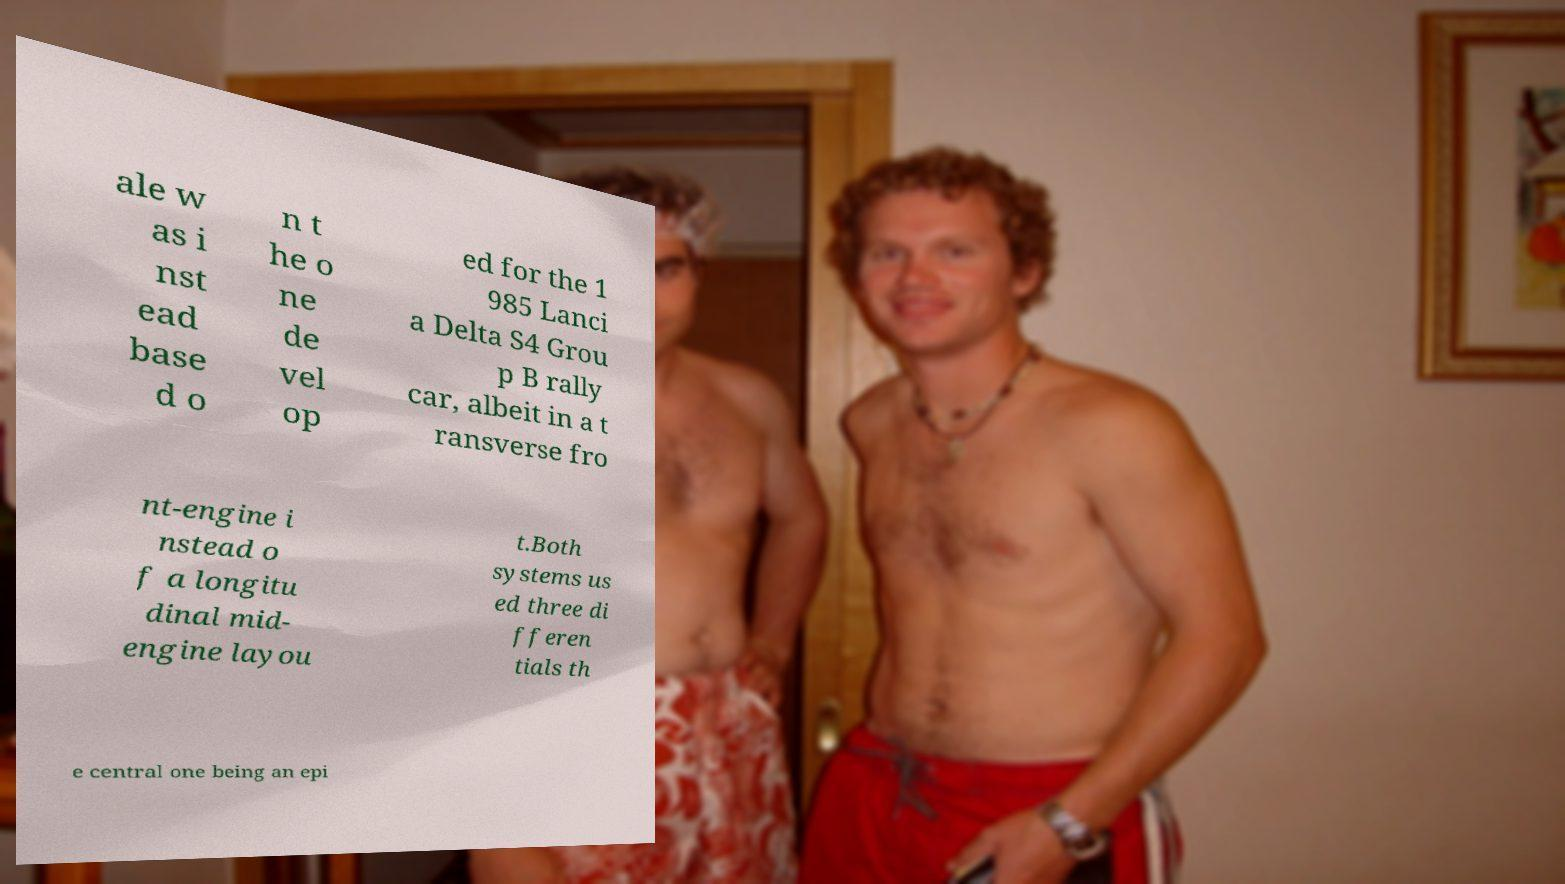For documentation purposes, I need the text within this image transcribed. Could you provide that? ale w as i nst ead base d o n t he o ne de vel op ed for the 1 985 Lanci a Delta S4 Grou p B rally car, albeit in a t ransverse fro nt-engine i nstead o f a longitu dinal mid- engine layou t.Both systems us ed three di fferen tials th e central one being an epi 